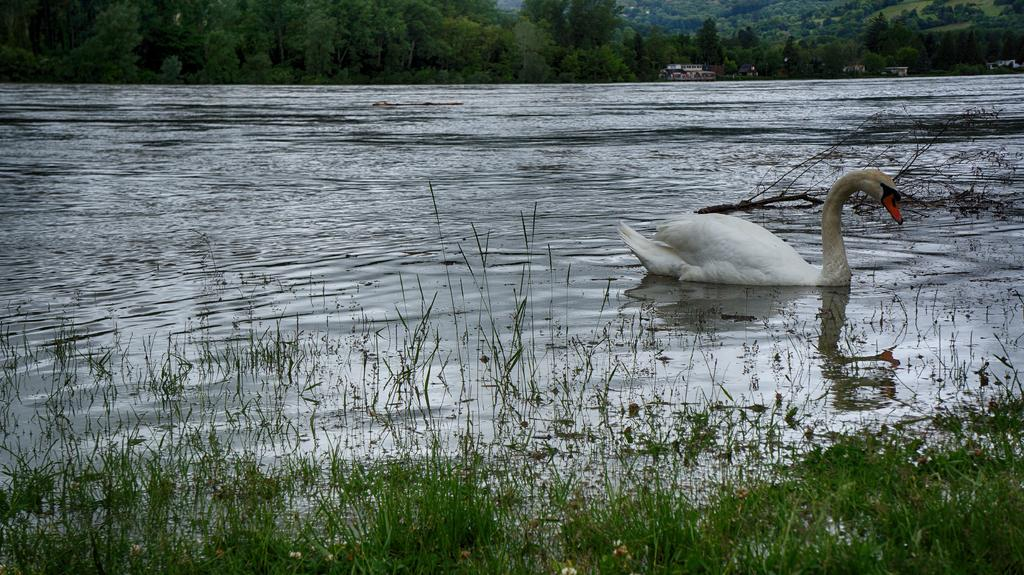What animal is present in the image? There is a swan in the image. Where is the swan located? The swan is on the water. What type of vegetation is visible in the image? Some part of the image is covered with grass. What can be seen in the background of the image? There are trees and sheds visible in the background of the image. What type of linen is draped over the swan in the image? There is no linen present in the image; the swan is on the water without any fabric draped over it. What is the title of the image? The provided facts do not mention a title for the image. 